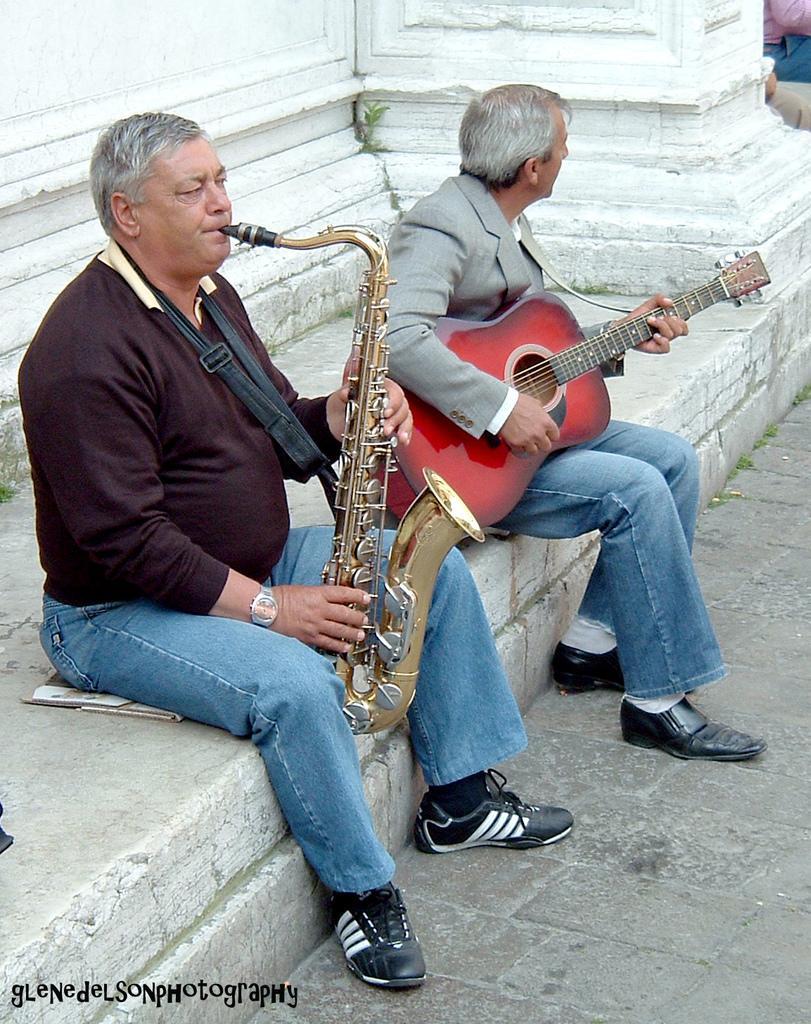In one or two sentences, can you explain what this image depicts? In this image there are two persons sitting on the floor playing musical instruments and at the background of the image there is a white color wall. 